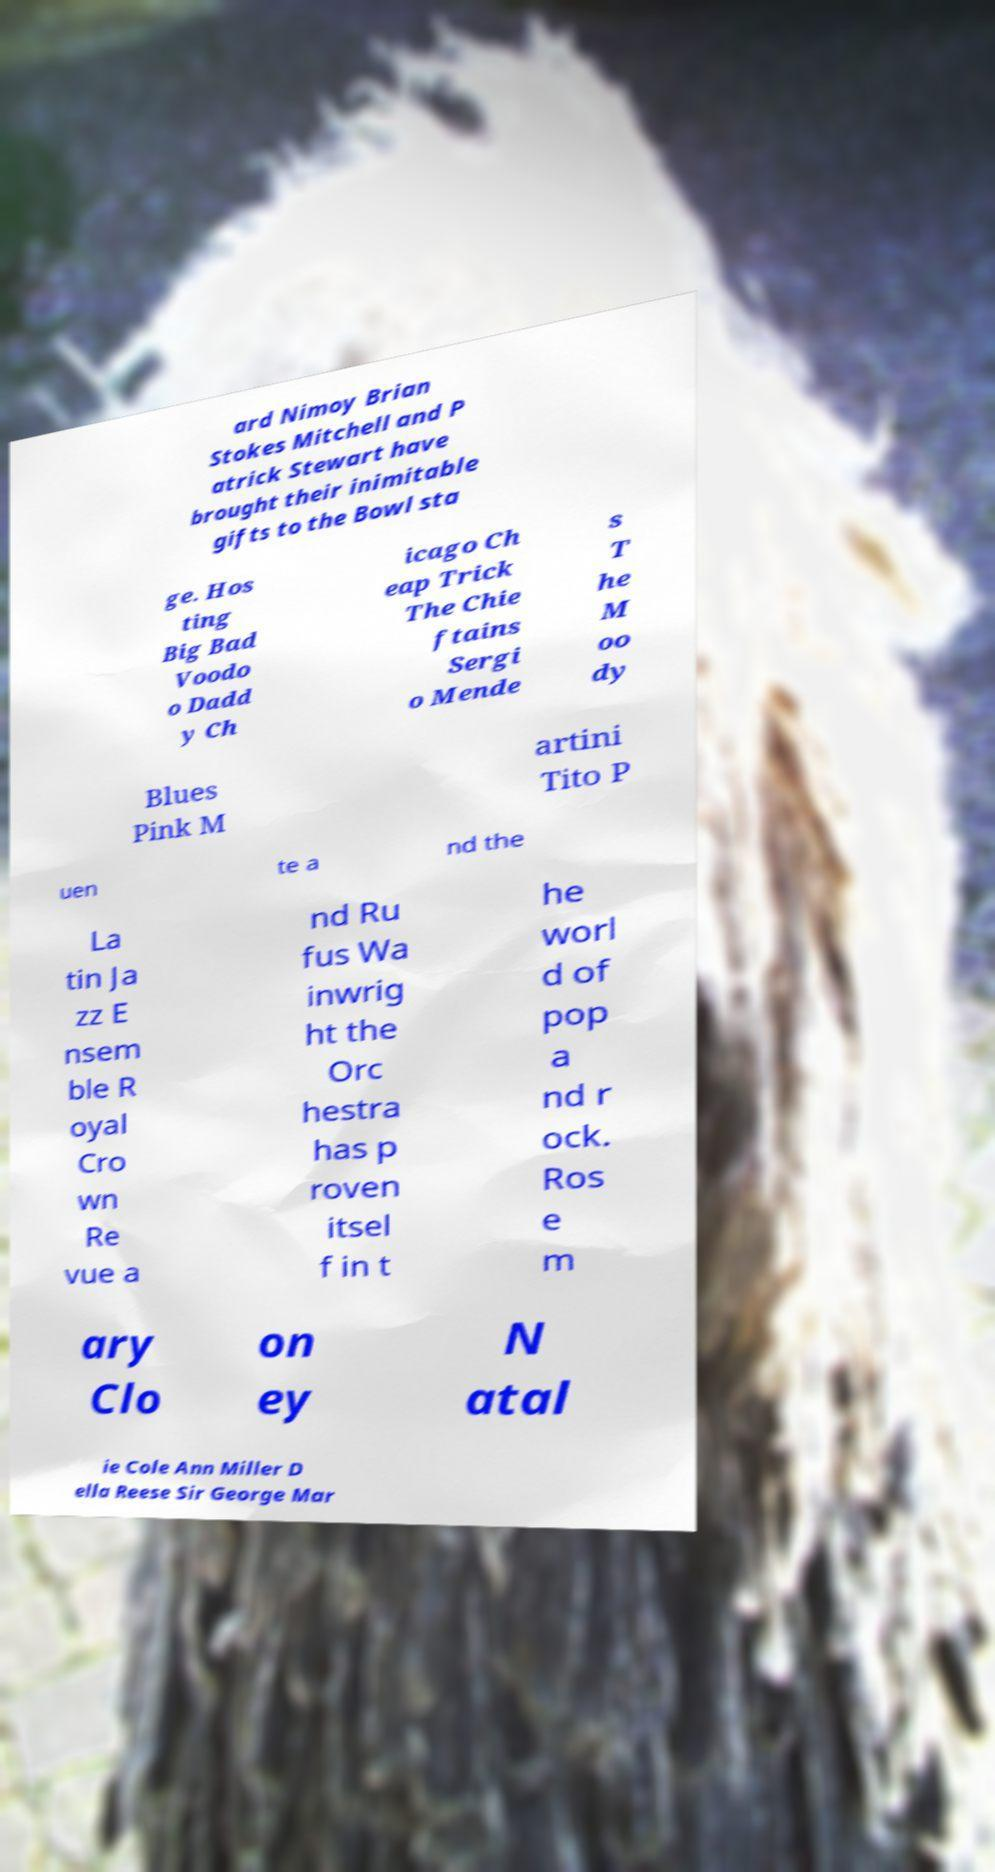Can you accurately transcribe the text from the provided image for me? ard Nimoy Brian Stokes Mitchell and P atrick Stewart have brought their inimitable gifts to the Bowl sta ge. Hos ting Big Bad Voodo o Dadd y Ch icago Ch eap Trick The Chie ftains Sergi o Mende s T he M oo dy Blues Pink M artini Tito P uen te a nd the La tin Ja zz E nsem ble R oyal Cro wn Re vue a nd Ru fus Wa inwrig ht the Orc hestra has p roven itsel f in t he worl d of pop a nd r ock. Ros e m ary Clo on ey N atal ie Cole Ann Miller D ella Reese Sir George Mar 